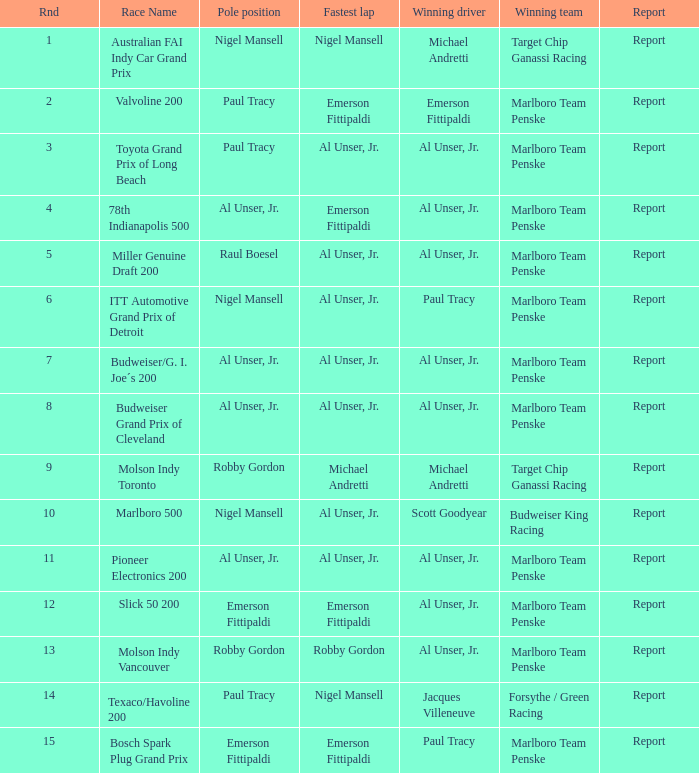What are the details of the race where michael andretti claimed victory and nigel mansell recorded the best lap time? Report. 